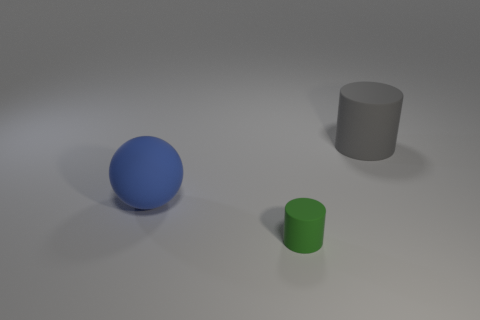Are there any other things that are the same size as the green cylinder?
Your answer should be very brief. No. There is a ball; does it have the same color as the cylinder that is to the right of the small green matte object?
Your response must be concise. No. What number of other rubber things are the same size as the green rubber thing?
Give a very brief answer. 0. Is the number of large objects that are behind the blue sphere less than the number of big rubber balls?
Give a very brief answer. No. There is a green matte cylinder; what number of large gray matte objects are to the left of it?
Your response must be concise. 0. There is a object that is on the right side of the matte cylinder that is in front of the large object on the right side of the tiny green thing; what size is it?
Your answer should be compact. Large. There is a big blue matte object; is it the same shape as the small thing in front of the gray rubber cylinder?
Make the answer very short. No. The blue ball that is the same material as the tiny cylinder is what size?
Your answer should be compact. Large. Is there any other thing of the same color as the big cylinder?
Provide a short and direct response. No. The thing that is in front of the large matte thing left of the matte cylinder behind the green matte thing is made of what material?
Offer a very short reply. Rubber. 